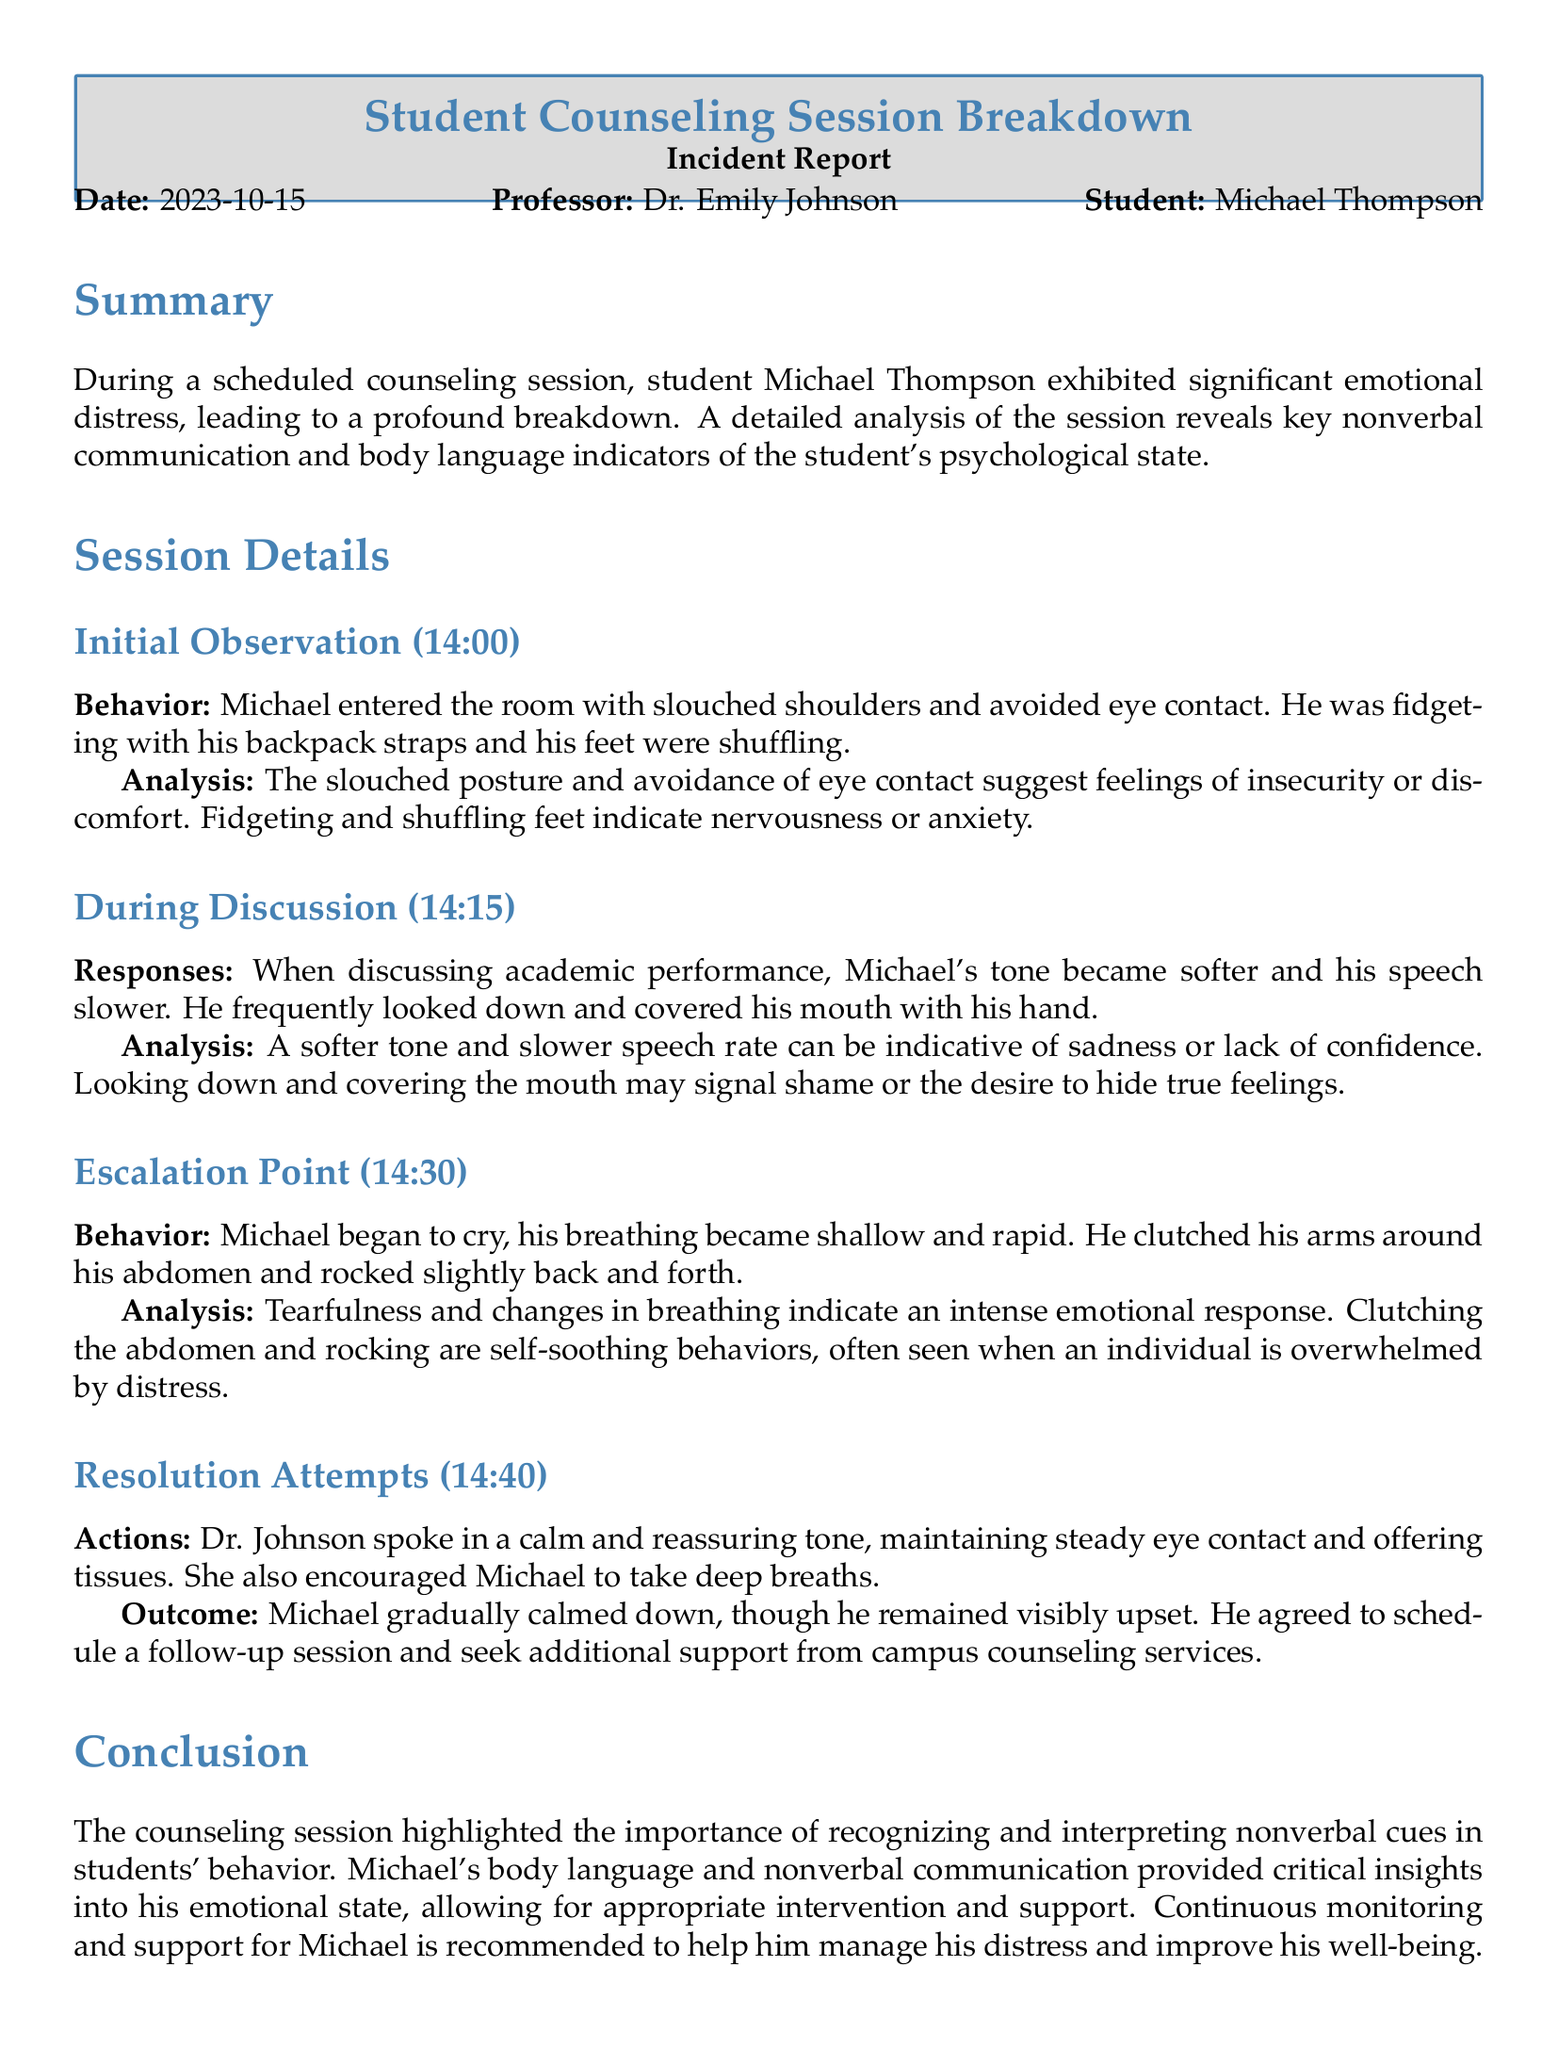What is the date of the counseling session? The date of the counseling session is mentioned in the document.
Answer: 2023-10-15 Who is the professor conducting the session? The professor's name is provided in the document under the professor section.
Answer: Dr. Emily Johnson What was Michael's behavior upon entering the room? The document describes Michael's behavior when he entered the room.
Answer: Slouched shoulders and avoided eye contact At what time did Michael begin to cry? The time of Michael's emotional distress is noted in the escalation point section.
Answer: 14:30 What action did Dr. Johnson take to help Michael during resolution attempts? The document outlines actions taken by Dr. Johnson to support Michael.
Answer: Maintained steady eye contact What was the outcome of the session in terms of follow-up? The document discusses the follow-up agreement Michael made after the session.
Answer: Agreed to schedule a follow-up session What nonverbal behavior indicated Michael's distress when discussing academic performance? The analysis in the document mentions specific nonverbal behaviors during discussion.
Answer: Looking down and covering his mouth What are the recommendations made for faculty? The recommendations section provides insights into suggested faculty training.
Answer: Training faculty on recognizing and interpreting nonverbal cues What time was the initial observation made? The time of the initial observation is noted in the session details section.
Answer: 14:00 